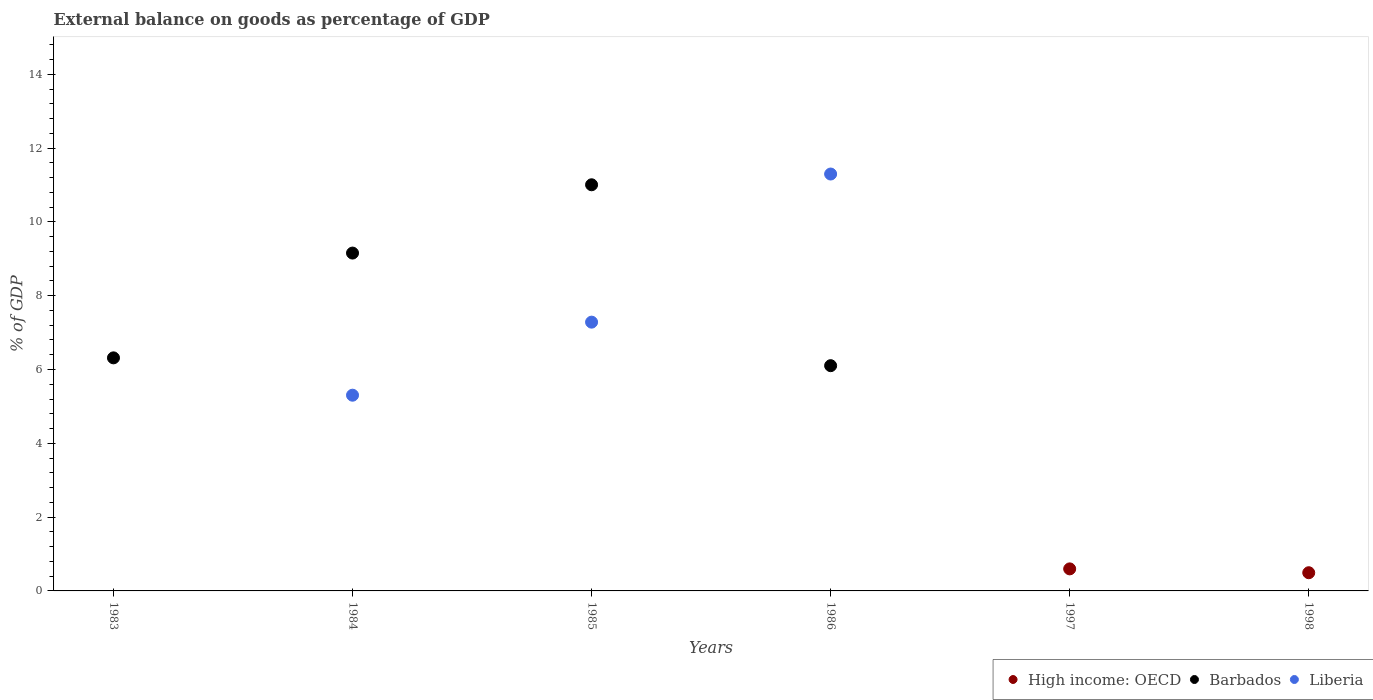How many different coloured dotlines are there?
Ensure brevity in your answer.  3. What is the external balance on goods as percentage of GDP in Barbados in 1984?
Your response must be concise. 9.15. Across all years, what is the maximum external balance on goods as percentage of GDP in High income: OECD?
Your answer should be compact. 0.6. In which year was the external balance on goods as percentage of GDP in Liberia maximum?
Offer a very short reply. 1986. What is the total external balance on goods as percentage of GDP in High income: OECD in the graph?
Make the answer very short. 1.09. What is the difference between the external balance on goods as percentage of GDP in Barbados in 1984 and that in 1986?
Provide a short and direct response. 3.05. What is the difference between the external balance on goods as percentage of GDP in Barbados in 1998 and the external balance on goods as percentage of GDP in Liberia in 1986?
Offer a terse response. -11.3. What is the average external balance on goods as percentage of GDP in Barbados per year?
Your response must be concise. 5.43. In the year 1985, what is the difference between the external balance on goods as percentage of GDP in Barbados and external balance on goods as percentage of GDP in Liberia?
Your answer should be compact. 3.72. Is the external balance on goods as percentage of GDP in Barbados in 1983 less than that in 1986?
Give a very brief answer. No. What is the difference between the highest and the second highest external balance on goods as percentage of GDP in Barbados?
Provide a short and direct response. 1.85. What is the difference between the highest and the lowest external balance on goods as percentage of GDP in High income: OECD?
Offer a terse response. 0.6. In how many years, is the external balance on goods as percentage of GDP in High income: OECD greater than the average external balance on goods as percentage of GDP in High income: OECD taken over all years?
Offer a terse response. 2. Is the sum of the external balance on goods as percentage of GDP in High income: OECD in 1997 and 1998 greater than the maximum external balance on goods as percentage of GDP in Liberia across all years?
Offer a terse response. No. Is it the case that in every year, the sum of the external balance on goods as percentage of GDP in High income: OECD and external balance on goods as percentage of GDP in Barbados  is greater than the external balance on goods as percentage of GDP in Liberia?
Keep it short and to the point. No. Does the external balance on goods as percentage of GDP in High income: OECD monotonically increase over the years?
Provide a short and direct response. No. What is the difference between two consecutive major ticks on the Y-axis?
Your response must be concise. 2. Does the graph contain any zero values?
Your answer should be very brief. Yes. Does the graph contain grids?
Make the answer very short. No. How many legend labels are there?
Your response must be concise. 3. How are the legend labels stacked?
Provide a succinct answer. Horizontal. What is the title of the graph?
Keep it short and to the point. External balance on goods as percentage of GDP. What is the label or title of the X-axis?
Your answer should be very brief. Years. What is the label or title of the Y-axis?
Ensure brevity in your answer.  % of GDP. What is the % of GDP of Barbados in 1983?
Your answer should be compact. 6.32. What is the % of GDP in Liberia in 1983?
Give a very brief answer. 0. What is the % of GDP in High income: OECD in 1984?
Ensure brevity in your answer.  0. What is the % of GDP of Barbados in 1984?
Keep it short and to the point. 9.15. What is the % of GDP of Liberia in 1984?
Provide a short and direct response. 5.3. What is the % of GDP in High income: OECD in 1985?
Offer a terse response. 0. What is the % of GDP in Barbados in 1985?
Offer a terse response. 11.01. What is the % of GDP of Liberia in 1985?
Offer a very short reply. 7.28. What is the % of GDP of Barbados in 1986?
Give a very brief answer. 6.1. What is the % of GDP of Liberia in 1986?
Offer a terse response. 11.3. What is the % of GDP in High income: OECD in 1997?
Ensure brevity in your answer.  0.6. What is the % of GDP in Barbados in 1997?
Provide a succinct answer. 0. What is the % of GDP in Liberia in 1997?
Offer a terse response. 0. What is the % of GDP of High income: OECD in 1998?
Offer a very short reply. 0.49. Across all years, what is the maximum % of GDP of High income: OECD?
Provide a succinct answer. 0.6. Across all years, what is the maximum % of GDP of Barbados?
Your response must be concise. 11.01. Across all years, what is the maximum % of GDP in Liberia?
Offer a very short reply. 11.3. Across all years, what is the minimum % of GDP of High income: OECD?
Give a very brief answer. 0. Across all years, what is the minimum % of GDP of Barbados?
Your response must be concise. 0. Across all years, what is the minimum % of GDP in Liberia?
Offer a very short reply. 0. What is the total % of GDP of High income: OECD in the graph?
Make the answer very short. 1.09. What is the total % of GDP in Barbados in the graph?
Make the answer very short. 32.58. What is the total % of GDP of Liberia in the graph?
Provide a short and direct response. 23.88. What is the difference between the % of GDP of Barbados in 1983 and that in 1984?
Provide a short and direct response. -2.84. What is the difference between the % of GDP in Barbados in 1983 and that in 1985?
Give a very brief answer. -4.69. What is the difference between the % of GDP in Barbados in 1983 and that in 1986?
Your response must be concise. 0.21. What is the difference between the % of GDP in Barbados in 1984 and that in 1985?
Ensure brevity in your answer.  -1.85. What is the difference between the % of GDP of Liberia in 1984 and that in 1985?
Your answer should be compact. -1.98. What is the difference between the % of GDP in Barbados in 1984 and that in 1986?
Your response must be concise. 3.05. What is the difference between the % of GDP in Liberia in 1984 and that in 1986?
Ensure brevity in your answer.  -5.99. What is the difference between the % of GDP in Barbados in 1985 and that in 1986?
Ensure brevity in your answer.  4.9. What is the difference between the % of GDP in Liberia in 1985 and that in 1986?
Give a very brief answer. -4.01. What is the difference between the % of GDP in High income: OECD in 1997 and that in 1998?
Make the answer very short. 0.1. What is the difference between the % of GDP of Barbados in 1983 and the % of GDP of Liberia in 1984?
Offer a very short reply. 1.01. What is the difference between the % of GDP in Barbados in 1983 and the % of GDP in Liberia in 1985?
Your answer should be compact. -0.97. What is the difference between the % of GDP of Barbados in 1983 and the % of GDP of Liberia in 1986?
Your answer should be compact. -4.98. What is the difference between the % of GDP of Barbados in 1984 and the % of GDP of Liberia in 1985?
Provide a short and direct response. 1.87. What is the difference between the % of GDP in Barbados in 1984 and the % of GDP in Liberia in 1986?
Make the answer very short. -2.14. What is the difference between the % of GDP in Barbados in 1985 and the % of GDP in Liberia in 1986?
Make the answer very short. -0.29. What is the average % of GDP of High income: OECD per year?
Make the answer very short. 0.18. What is the average % of GDP in Barbados per year?
Give a very brief answer. 5.43. What is the average % of GDP in Liberia per year?
Make the answer very short. 3.98. In the year 1984, what is the difference between the % of GDP of Barbados and % of GDP of Liberia?
Your answer should be very brief. 3.85. In the year 1985, what is the difference between the % of GDP of Barbados and % of GDP of Liberia?
Your response must be concise. 3.72. In the year 1986, what is the difference between the % of GDP in Barbados and % of GDP in Liberia?
Offer a very short reply. -5.19. What is the ratio of the % of GDP of Barbados in 1983 to that in 1984?
Ensure brevity in your answer.  0.69. What is the ratio of the % of GDP of Barbados in 1983 to that in 1985?
Provide a short and direct response. 0.57. What is the ratio of the % of GDP in Barbados in 1983 to that in 1986?
Provide a succinct answer. 1.03. What is the ratio of the % of GDP in Barbados in 1984 to that in 1985?
Provide a succinct answer. 0.83. What is the ratio of the % of GDP of Liberia in 1984 to that in 1985?
Ensure brevity in your answer.  0.73. What is the ratio of the % of GDP in Barbados in 1984 to that in 1986?
Provide a short and direct response. 1.5. What is the ratio of the % of GDP in Liberia in 1984 to that in 1986?
Provide a short and direct response. 0.47. What is the ratio of the % of GDP of Barbados in 1985 to that in 1986?
Ensure brevity in your answer.  1.8. What is the ratio of the % of GDP in Liberia in 1985 to that in 1986?
Your response must be concise. 0.64. What is the ratio of the % of GDP of High income: OECD in 1997 to that in 1998?
Offer a very short reply. 1.21. What is the difference between the highest and the second highest % of GDP in Barbados?
Provide a succinct answer. 1.85. What is the difference between the highest and the second highest % of GDP in Liberia?
Give a very brief answer. 4.01. What is the difference between the highest and the lowest % of GDP in High income: OECD?
Ensure brevity in your answer.  0.6. What is the difference between the highest and the lowest % of GDP of Barbados?
Offer a very short reply. 11.01. What is the difference between the highest and the lowest % of GDP in Liberia?
Keep it short and to the point. 11.3. 